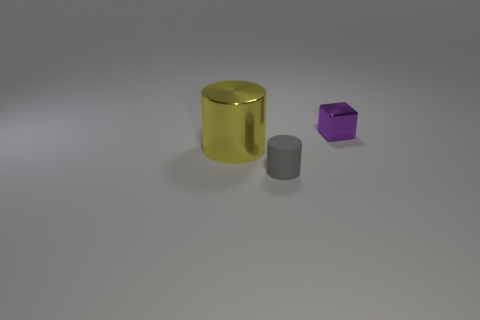Are the objects arranged in a particular pattern or randomly? The objects seem to be placed without a specific pattern; their arrangement seems random with varying distances between them. This could be an artistic choice or for the purpose of showcasing the objects individually. 